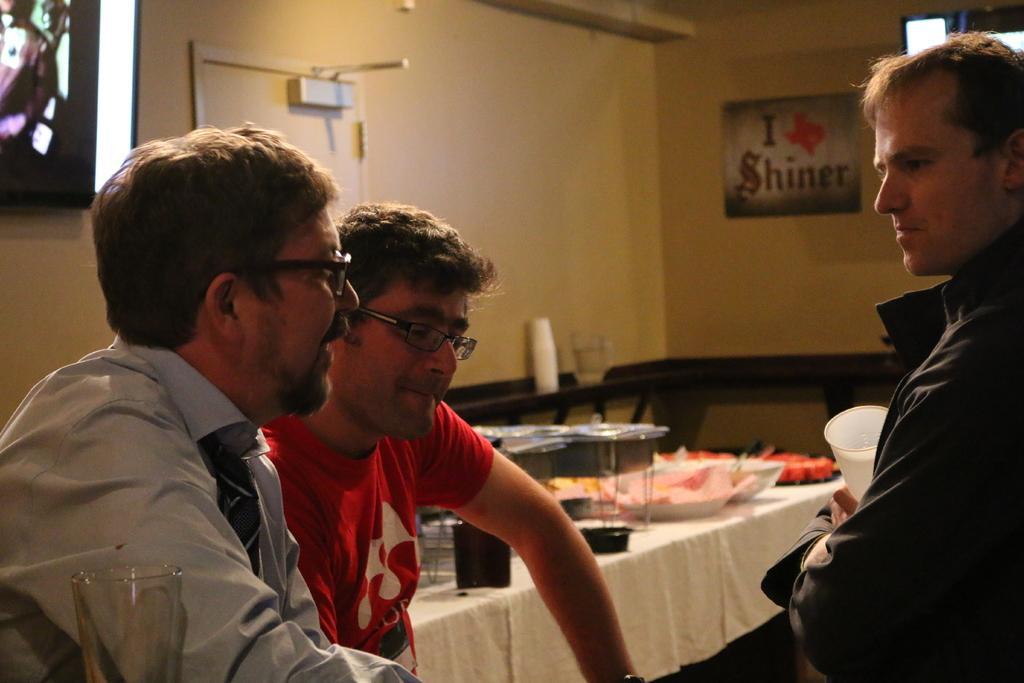Could you give a brief overview of what you see in this image? In the foreground of this image, there are three men and a glass and also a man holding a glass. In the background, there are few objects on the table, wall, jar, door, screen and the poster. 